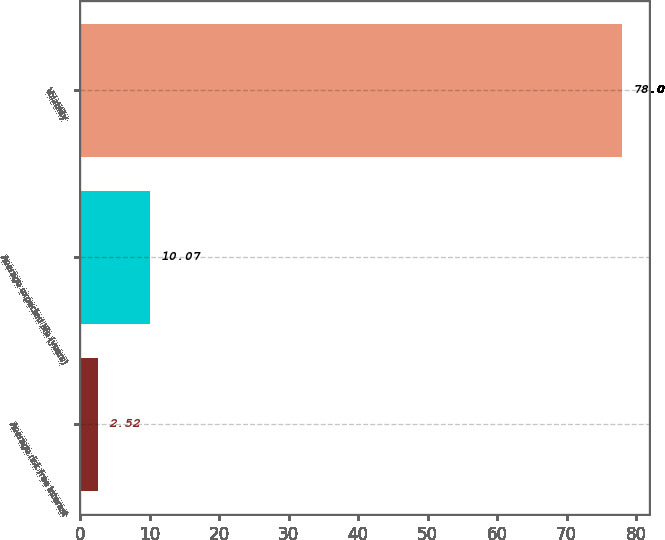Convert chart to OTSL. <chart><loc_0><loc_0><loc_500><loc_500><bar_chart><fcel>Average risk free interest<fcel>Average expected life (years)<fcel>Volatility<nl><fcel>2.52<fcel>10.07<fcel>78<nl></chart> 